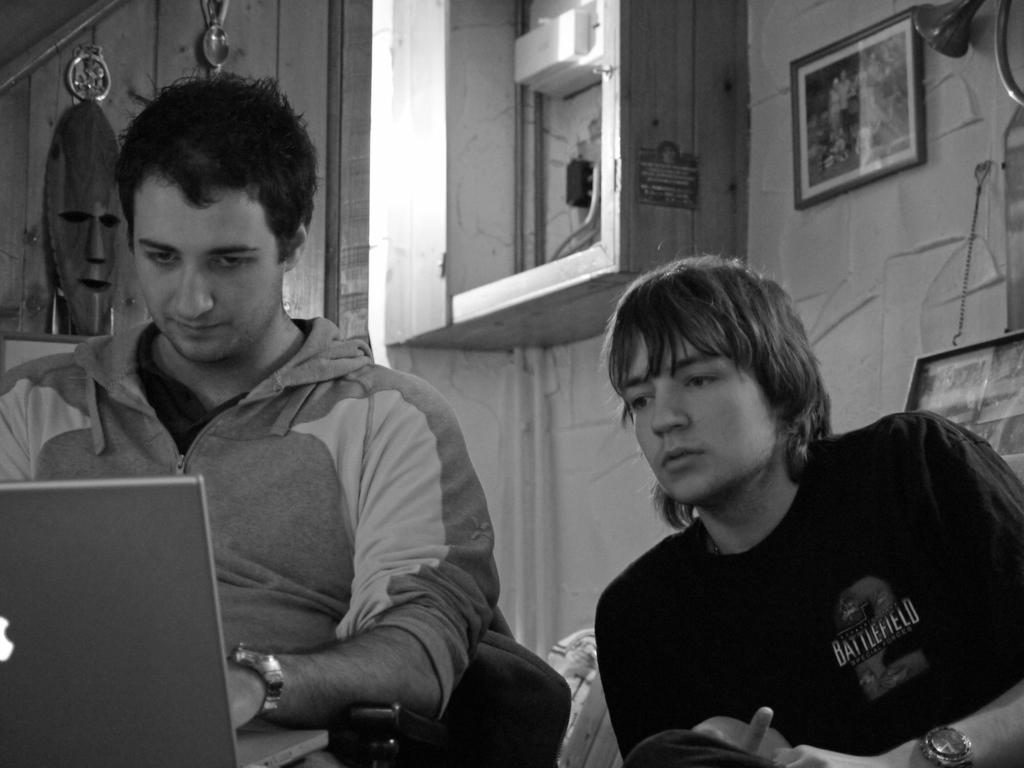How many people are wearing dresses in the image? There are two people with dresses in the image. What is one person doing in the image? One person is using a laptop in the image. What can be seen in the background of the image? There is a frame and a current board in the background of the image, as well as objects on the wall. What type of marble is being used to write on the current board in the image? There is no marble present in the image, and the current board is not being written on. What is the oatmeal being used for in the image? There is no oatmeal present in the image. 